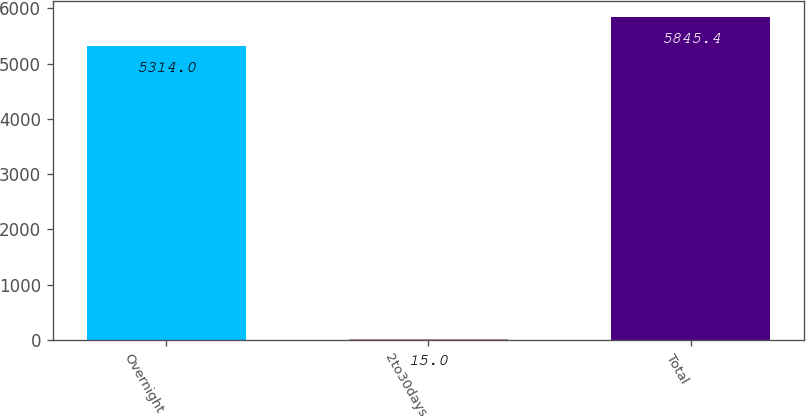Convert chart. <chart><loc_0><loc_0><loc_500><loc_500><bar_chart><fcel>Overnight<fcel>2to30days<fcel>Total<nl><fcel>5314<fcel>15<fcel>5845.4<nl></chart> 